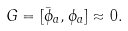<formula> <loc_0><loc_0><loc_500><loc_500>G = [ \bar { \phi } _ { a } , \phi _ { a } ] \approx 0 .</formula> 